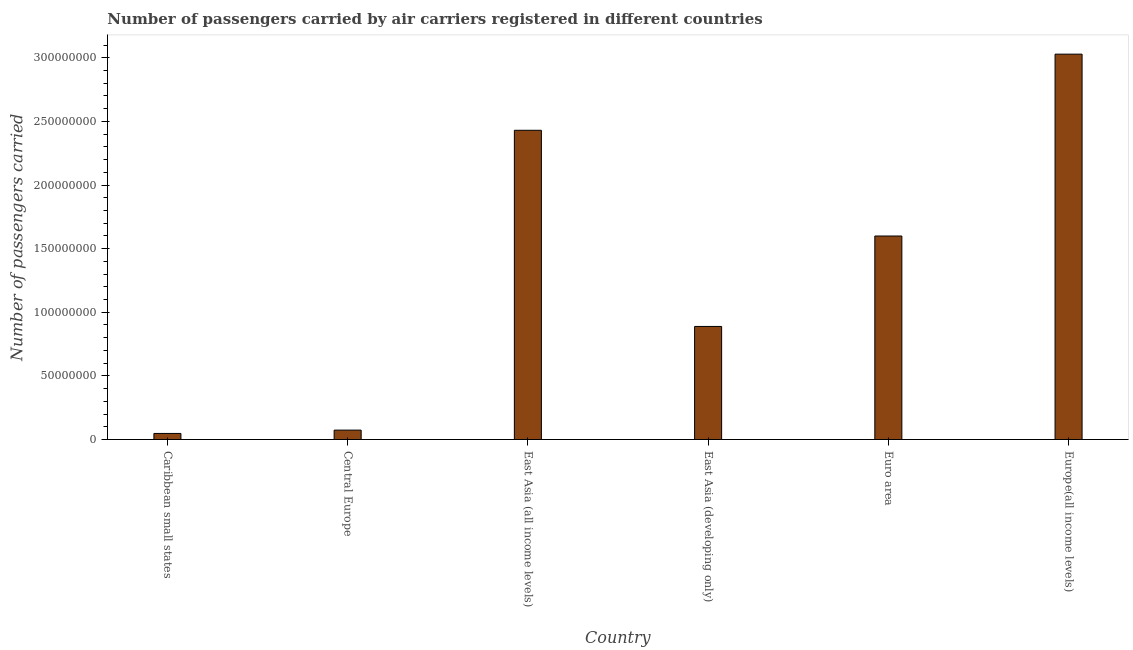Does the graph contain grids?
Provide a succinct answer. No. What is the title of the graph?
Provide a short and direct response. Number of passengers carried by air carriers registered in different countries. What is the label or title of the X-axis?
Offer a terse response. Country. What is the label or title of the Y-axis?
Make the answer very short. Number of passengers carried. What is the number of passengers carried in Europe(all income levels)?
Keep it short and to the point. 3.03e+08. Across all countries, what is the maximum number of passengers carried?
Offer a very short reply. 3.03e+08. Across all countries, what is the minimum number of passengers carried?
Make the answer very short. 4.78e+06. In which country was the number of passengers carried maximum?
Your answer should be very brief. Europe(all income levels). In which country was the number of passengers carried minimum?
Provide a succinct answer. Caribbean small states. What is the sum of the number of passengers carried?
Offer a terse response. 8.07e+08. What is the difference between the number of passengers carried in Central Europe and Euro area?
Make the answer very short. -1.53e+08. What is the average number of passengers carried per country?
Your answer should be very brief. 1.34e+08. What is the median number of passengers carried?
Your response must be concise. 1.24e+08. In how many countries, is the number of passengers carried greater than 100000000 ?
Your answer should be compact. 3. What is the ratio of the number of passengers carried in East Asia (all income levels) to that in East Asia (developing only)?
Offer a very short reply. 2.73. Is the difference between the number of passengers carried in Central Europe and Euro area greater than the difference between any two countries?
Provide a short and direct response. No. What is the difference between the highest and the second highest number of passengers carried?
Provide a short and direct response. 5.98e+07. What is the difference between the highest and the lowest number of passengers carried?
Your response must be concise. 2.98e+08. In how many countries, is the number of passengers carried greater than the average number of passengers carried taken over all countries?
Keep it short and to the point. 3. Are all the bars in the graph horizontal?
Offer a very short reply. No. How many countries are there in the graph?
Ensure brevity in your answer.  6. What is the Number of passengers carried of Caribbean small states?
Your answer should be compact. 4.78e+06. What is the Number of passengers carried in Central Europe?
Your answer should be very brief. 7.39e+06. What is the Number of passengers carried in East Asia (all income levels)?
Ensure brevity in your answer.  2.43e+08. What is the Number of passengers carried of East Asia (developing only)?
Your answer should be very brief. 8.89e+07. What is the Number of passengers carried of Euro area?
Offer a very short reply. 1.60e+08. What is the Number of passengers carried in Europe(all income levels)?
Your answer should be compact. 3.03e+08. What is the difference between the Number of passengers carried in Caribbean small states and Central Europe?
Your answer should be compact. -2.61e+06. What is the difference between the Number of passengers carried in Caribbean small states and East Asia (all income levels)?
Provide a succinct answer. -2.38e+08. What is the difference between the Number of passengers carried in Caribbean small states and East Asia (developing only)?
Offer a very short reply. -8.41e+07. What is the difference between the Number of passengers carried in Caribbean small states and Euro area?
Offer a terse response. -1.55e+08. What is the difference between the Number of passengers carried in Caribbean small states and Europe(all income levels)?
Offer a very short reply. -2.98e+08. What is the difference between the Number of passengers carried in Central Europe and East Asia (all income levels)?
Make the answer very short. -2.36e+08. What is the difference between the Number of passengers carried in Central Europe and East Asia (developing only)?
Your response must be concise. -8.15e+07. What is the difference between the Number of passengers carried in Central Europe and Euro area?
Make the answer very short. -1.53e+08. What is the difference between the Number of passengers carried in Central Europe and Europe(all income levels)?
Give a very brief answer. -2.95e+08. What is the difference between the Number of passengers carried in East Asia (all income levels) and East Asia (developing only)?
Make the answer very short. 1.54e+08. What is the difference between the Number of passengers carried in East Asia (all income levels) and Euro area?
Ensure brevity in your answer.  8.31e+07. What is the difference between the Number of passengers carried in East Asia (all income levels) and Europe(all income levels)?
Ensure brevity in your answer.  -5.98e+07. What is the difference between the Number of passengers carried in East Asia (developing only) and Euro area?
Keep it short and to the point. -7.11e+07. What is the difference between the Number of passengers carried in East Asia (developing only) and Europe(all income levels)?
Your answer should be compact. -2.14e+08. What is the difference between the Number of passengers carried in Euro area and Europe(all income levels)?
Give a very brief answer. -1.43e+08. What is the ratio of the Number of passengers carried in Caribbean small states to that in Central Europe?
Keep it short and to the point. 0.65. What is the ratio of the Number of passengers carried in Caribbean small states to that in East Asia (all income levels)?
Offer a terse response. 0.02. What is the ratio of the Number of passengers carried in Caribbean small states to that in East Asia (developing only)?
Offer a terse response. 0.05. What is the ratio of the Number of passengers carried in Caribbean small states to that in Europe(all income levels)?
Keep it short and to the point. 0.02. What is the ratio of the Number of passengers carried in Central Europe to that in East Asia (all income levels)?
Your answer should be compact. 0.03. What is the ratio of the Number of passengers carried in Central Europe to that in East Asia (developing only)?
Keep it short and to the point. 0.08. What is the ratio of the Number of passengers carried in Central Europe to that in Euro area?
Provide a short and direct response. 0.05. What is the ratio of the Number of passengers carried in Central Europe to that in Europe(all income levels)?
Your answer should be very brief. 0.02. What is the ratio of the Number of passengers carried in East Asia (all income levels) to that in East Asia (developing only)?
Ensure brevity in your answer.  2.73. What is the ratio of the Number of passengers carried in East Asia (all income levels) to that in Euro area?
Offer a terse response. 1.52. What is the ratio of the Number of passengers carried in East Asia (all income levels) to that in Europe(all income levels)?
Keep it short and to the point. 0.8. What is the ratio of the Number of passengers carried in East Asia (developing only) to that in Euro area?
Your response must be concise. 0.56. What is the ratio of the Number of passengers carried in East Asia (developing only) to that in Europe(all income levels)?
Give a very brief answer. 0.29. What is the ratio of the Number of passengers carried in Euro area to that in Europe(all income levels)?
Your answer should be compact. 0.53. 